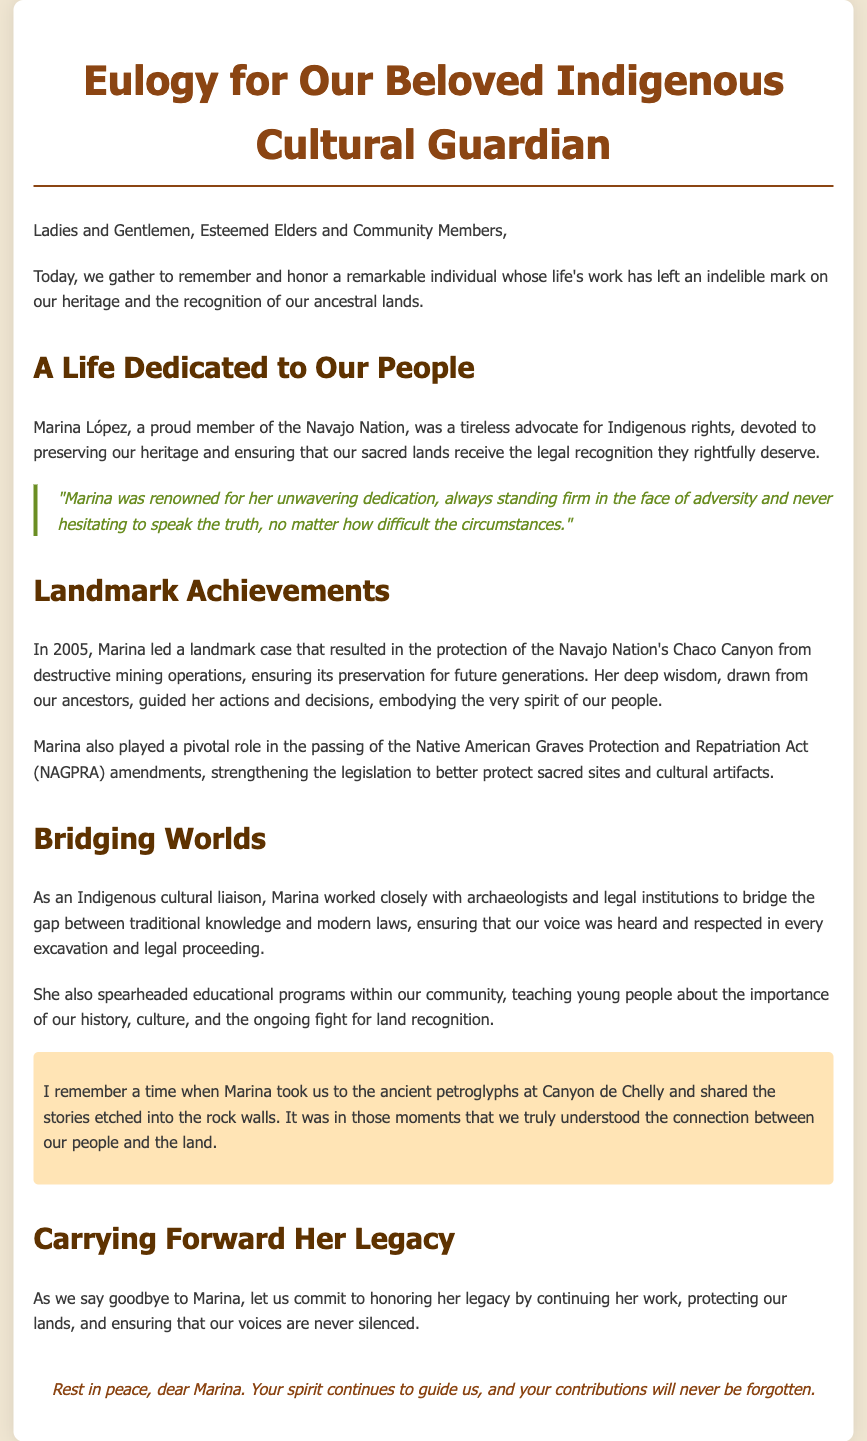What was Marina López's nationality? The document states that Marina López was a proud member of the Navajo Nation, indicating her nationality.
Answer: Navajo Nation What year did Marina lead a landmark case for Chaco Canyon? The document specifies that the landmark case for Chaco Canyon was led by Marina in 2005.
Answer: 2005 What act did Marina help strengthen? The eulogy mentions that Marina played a pivotal role in the passing of the Native American Graves Protection and Repatriation Act (NAGPRA) amendments.
Answer: NAGPRA What did Marina teach young people in the community? The document highlights that she taught young people about the importance of history, culture, and land recognition.
Answer: History, culture, and land recognition What is Marina described as in her role with archaeologists and legal institutions? The eulogy describes Marina as an Indigenous cultural liaison who worked closely with archaeologists and legal institutions.
Answer: Indigenous cultural liaison What does the eulogy encourage the audience to commit to in honor of Marina? The audience is encouraged to commit to continuing Marina's work to protect their lands and ensure their voices are heard.
Answer: Continuing her work Why is Marina's spirit mentioned at the end of the eulogy? The eulogy states that Marina's spirit continues to guide the community, emphasizing her ongoing influence even after her passing.
Answer: Ongoing influence What type of document is this text? The formatting and content indicate that this document serves as a eulogy for an individual who contributed significantly to Indigenous rights.
Answer: Eulogy 